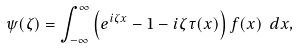<formula> <loc_0><loc_0><loc_500><loc_500>\psi ( \zeta ) = \int _ { - \infty } ^ { \infty } \left ( e ^ { i \zeta x } - 1 - i \zeta \tau ( x ) \right ) f ( x ) \ d x ,</formula> 